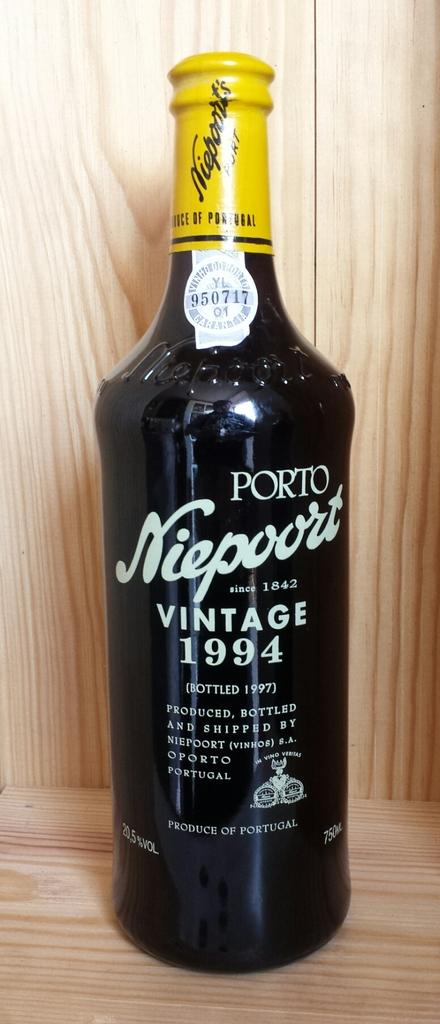<image>
Summarize the visual content of the image. A bottle with a yellow top says Vintage 1994. 